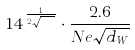<formula> <loc_0><loc_0><loc_500><loc_500>1 4 ^ { \frac { 1 } { 2 \sqrt { d _ { W } } } } \cdot \frac { 2 . 6 } { N e \sqrt { d _ { W } } }</formula> 